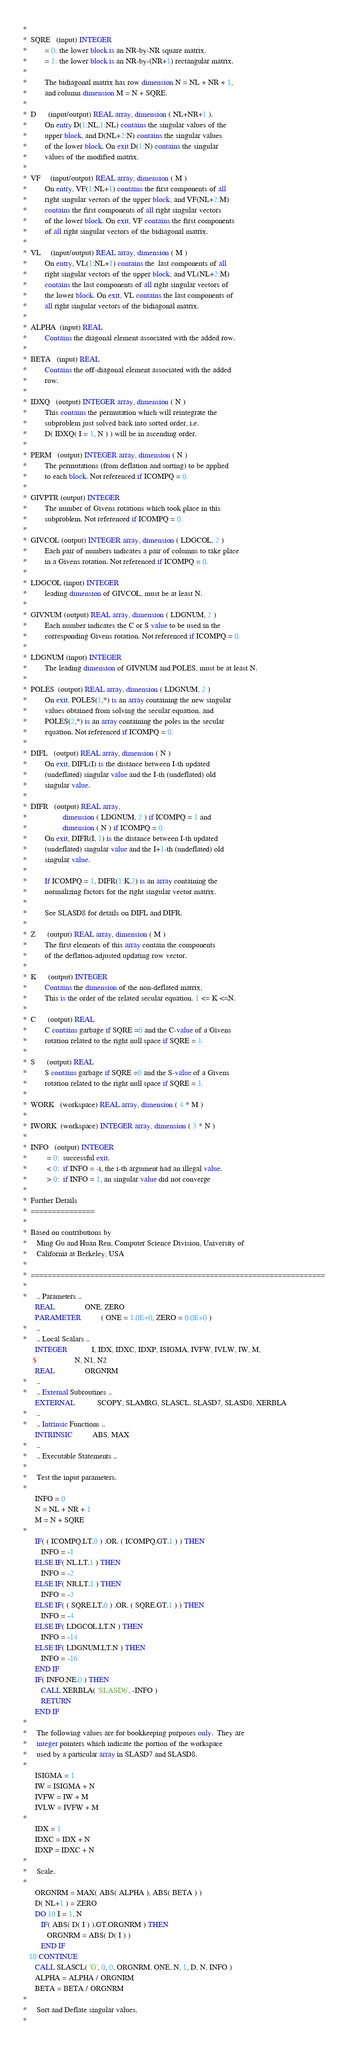<code> <loc_0><loc_0><loc_500><loc_500><_FORTRAN_>*
*  SQRE   (input) INTEGER
*         = 0: the lower block is an NR-by-NR square matrix.
*         = 1: the lower block is an NR-by-(NR+1) rectangular matrix.
*
*         The bidiagonal matrix has row dimension N = NL + NR + 1,
*         and column dimension M = N + SQRE.
*
*  D      (input/output) REAL array, dimension ( NL+NR+1 ).
*         On entry D(1:NL,1:NL) contains the singular values of the
*         upper block, and D(NL+2:N) contains the singular values
*         of the lower block. On exit D(1:N) contains the singular
*         values of the modified matrix.
*
*  VF     (input/output) REAL array, dimension ( M )
*         On entry, VF(1:NL+1) contains the first components of all
*         right singular vectors of the upper block; and VF(NL+2:M)
*         contains the first components of all right singular vectors
*         of the lower block. On exit, VF contains the first components
*         of all right singular vectors of the bidiagonal matrix.
*
*  VL     (input/output) REAL array, dimension ( M )
*         On entry, VL(1:NL+1) contains the  last components of all
*         right singular vectors of the upper block; and VL(NL+2:M)
*         contains the last components of all right singular vectors of
*         the lower block. On exit, VL contains the last components of
*         all right singular vectors of the bidiagonal matrix.
*
*  ALPHA  (input) REAL
*         Contains the diagonal element associated with the added row.
*
*  BETA   (input) REAL
*         Contains the off-diagonal element associated with the added
*         row.
*
*  IDXQ   (output) INTEGER array, dimension ( N )
*         This contains the permutation which will reintegrate the
*         subproblem just solved back into sorted order, i.e.
*         D( IDXQ( I = 1, N ) ) will be in ascending order.
*
*  PERM   (output) INTEGER array, dimension ( N )
*         The permutations (from deflation and sorting) to be applied
*         to each block. Not referenced if ICOMPQ = 0.
*
*  GIVPTR (output) INTEGER
*         The number of Givens rotations which took place in this
*         subproblem. Not referenced if ICOMPQ = 0.
*
*  GIVCOL (output) INTEGER array, dimension ( LDGCOL, 2 )
*         Each pair of numbers indicates a pair of columns to take place
*         in a Givens rotation. Not referenced if ICOMPQ = 0.
*
*  LDGCOL (input) INTEGER
*         leading dimension of GIVCOL, must be at least N.
*
*  GIVNUM (output) REAL array, dimension ( LDGNUM, 2 )
*         Each number indicates the C or S value to be used in the
*         corresponding Givens rotation. Not referenced if ICOMPQ = 0.
*
*  LDGNUM (input) INTEGER
*         The leading dimension of GIVNUM and POLES, must be at least N.
*
*  POLES  (output) REAL array, dimension ( LDGNUM, 2 )
*         On exit, POLES(1,*) is an array containing the new singular
*         values obtained from solving the secular equation, and
*         POLES(2,*) is an array containing the poles in the secular
*         equation. Not referenced if ICOMPQ = 0.
*
*  DIFL   (output) REAL array, dimension ( N )
*         On exit, DIFL(I) is the distance between I-th updated
*         (undeflated) singular value and the I-th (undeflated) old
*         singular value.
*
*  DIFR   (output) REAL array,
*                  dimension ( LDGNUM, 2 ) if ICOMPQ = 1 and
*                  dimension ( N ) if ICOMPQ = 0.
*         On exit, DIFR(I, 1) is the distance between I-th updated
*         (undeflated) singular value and the I+1-th (undeflated) old
*         singular value.
*
*         If ICOMPQ = 1, DIFR(1:K,2) is an array containing the
*         normalizing factors for the right singular vector matrix.
*
*         See SLASD8 for details on DIFL and DIFR.
*
*  Z      (output) REAL array, dimension ( M )
*         The first elements of this array contain the components
*         of the deflation-adjusted updating row vector.
*
*  K      (output) INTEGER
*         Contains the dimension of the non-deflated matrix,
*         This is the order of the related secular equation. 1 <= K <=N.
*
*  C      (output) REAL
*         C contains garbage if SQRE =0 and the C-value of a Givens
*         rotation related to the right null space if SQRE = 1.
*
*  S      (output) REAL
*         S contains garbage if SQRE =0 and the S-value of a Givens
*         rotation related to the right null space if SQRE = 1.
*
*  WORK   (workspace) REAL array, dimension ( 4 * M )
*
*  IWORK  (workspace) INTEGER array, dimension ( 3 * N )
*
*  INFO   (output) INTEGER
*          = 0:  successful exit.
*          < 0:  if INFO = -i, the i-th argument had an illegal value.
*          > 0:  if INFO = 1, an singular value did not converge
*
*  Further Details
*  ===============
*
*  Based on contributions by
*     Ming Gu and Huan Ren, Computer Science Division, University of
*     California at Berkeley, USA
*
*  =====================================================================
*
*     .. Parameters ..
      REAL               ONE, ZERO
      PARAMETER          ( ONE = 1.0E+0, ZERO = 0.0E+0 )
*     ..
*     .. Local Scalars ..
      INTEGER            I, IDX, IDXC, IDXP, ISIGMA, IVFW, IVLW, IW, M,
     $                   N, N1, N2
      REAL               ORGNRM
*     ..
*     .. External Subroutines ..
      EXTERNAL           SCOPY, SLAMRG, SLASCL, SLASD7, SLASD8, XERBLA
*     ..
*     .. Intrinsic Functions ..
      INTRINSIC          ABS, MAX
*     ..
*     .. Executable Statements ..
*
*     Test the input parameters.
*
      INFO = 0
      N = NL + NR + 1
      M = N + SQRE
*
      IF( ( ICOMPQ.LT.0 ) .OR. ( ICOMPQ.GT.1 ) ) THEN
         INFO = -1
      ELSE IF( NL.LT.1 ) THEN
         INFO = -2
      ELSE IF( NR.LT.1 ) THEN
         INFO = -3
      ELSE IF( ( SQRE.LT.0 ) .OR. ( SQRE.GT.1 ) ) THEN
         INFO = -4
      ELSE IF( LDGCOL.LT.N ) THEN
         INFO = -14
      ELSE IF( LDGNUM.LT.N ) THEN
         INFO = -16
      END IF
      IF( INFO.NE.0 ) THEN
         CALL XERBLA( 'SLASD6', -INFO )
         RETURN
      END IF
*
*     The following values are for bookkeeping purposes only.  They are
*     integer pointers which indicate the portion of the workspace
*     used by a particular array in SLASD7 and SLASD8.
*
      ISIGMA = 1
      IW = ISIGMA + N
      IVFW = IW + M
      IVLW = IVFW + M
*
      IDX = 1
      IDXC = IDX + N
      IDXP = IDXC + N
*
*     Scale.
*
      ORGNRM = MAX( ABS( ALPHA ), ABS( BETA ) )
      D( NL+1 ) = ZERO
      DO 10 I = 1, N
         IF( ABS( D( I ) ).GT.ORGNRM ) THEN
            ORGNRM = ABS( D( I ) )
         END IF
   10 CONTINUE
      CALL SLASCL( 'G', 0, 0, ORGNRM, ONE, N, 1, D, N, INFO )
      ALPHA = ALPHA / ORGNRM
      BETA = BETA / ORGNRM
*
*     Sort and Deflate singular values.
*</code> 